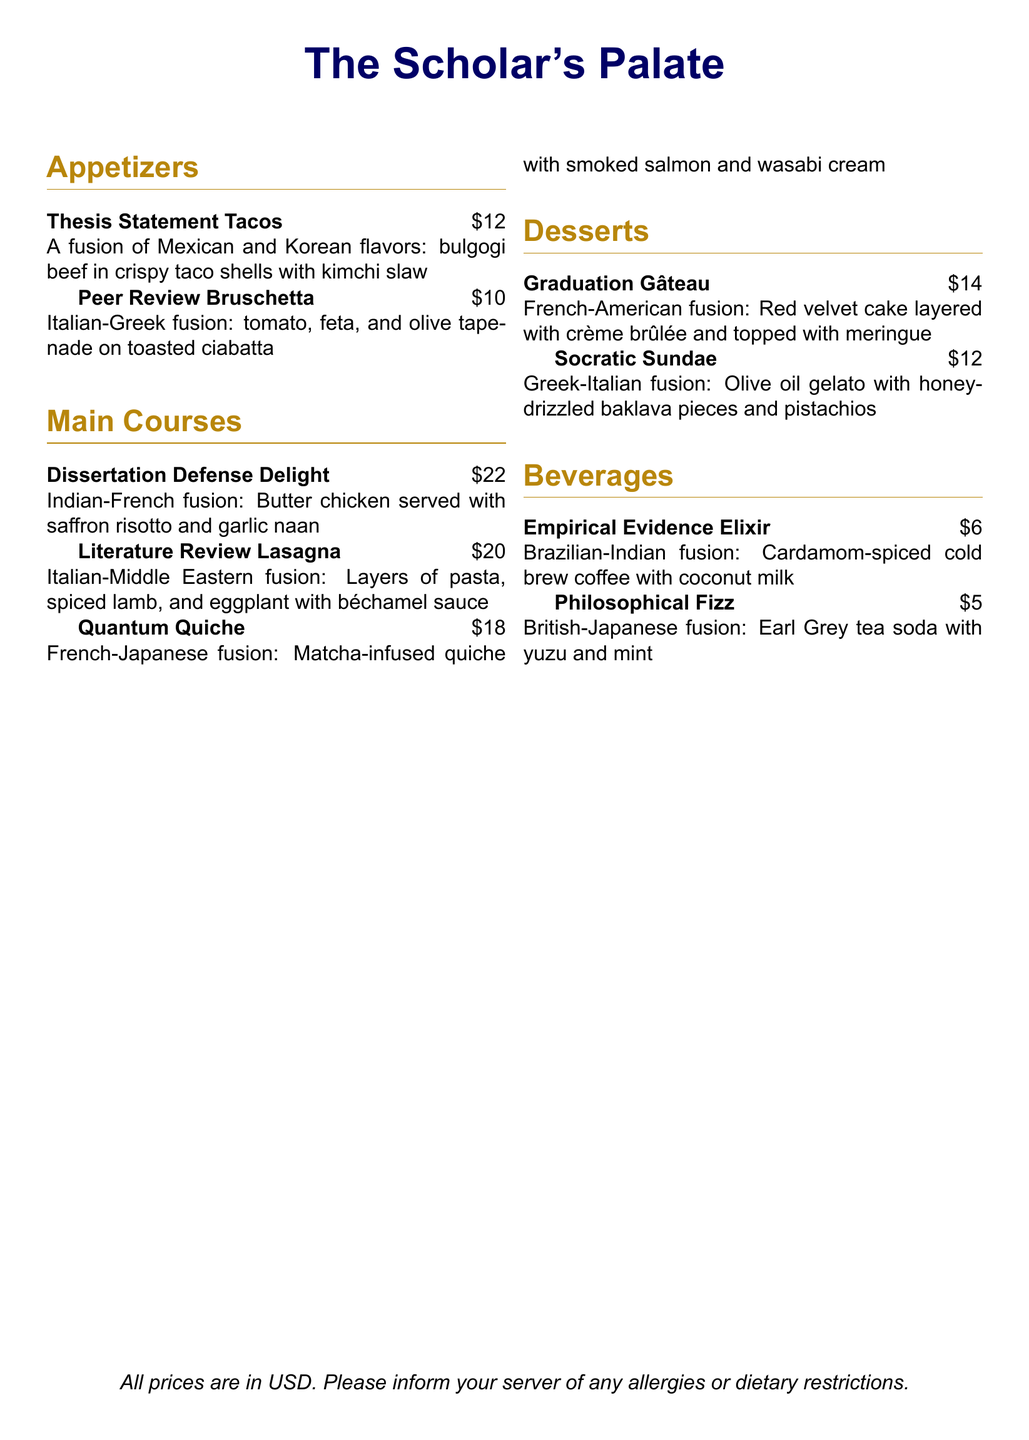what is the price of Thesis Statement Tacos? The price of Thesis Statement Tacos is listed in the document, which is $12.
Answer: $12 how many appetizers are offered on the menu? The menu includes a total of two appetizers, as seen in the appetizers section.
Answer: 2 what fusion cuisines are included in the Dissertation Defense Delight? The Dissertation Defense Delight features Indian and French fusion cuisines.
Answer: Indian-French what is the main ingredient in the Quantum Quiche? The main ingredient in the Quantum Quiche is matcha, which is mentioned in its description.
Answer: matcha which dessert includes baklava? The dessert that includes baklava is the Socratic Sundae, as stated in its description.
Answer: Socratic Sundae what type of beverage is the Empirical Evidence Elixir? The Empirical Evidence Elixir is a coffee beverage that combines Brazilian and Indian flavors.
Answer: coffee what is the total cost of the appetizers? The total cost of the appetizers is the sum of their prices: $12 + $10 = $22.
Answer: $22 which dish is inspired by American cuisine? The dish inspired by American cuisine is the Graduation Gâteau, as it’s a French-American fusion.
Answer: Graduation Gâteau how many main courses are listed on the menu? The menu includes a total of three main courses, as mentioned in the main courses section.
Answer: 3 